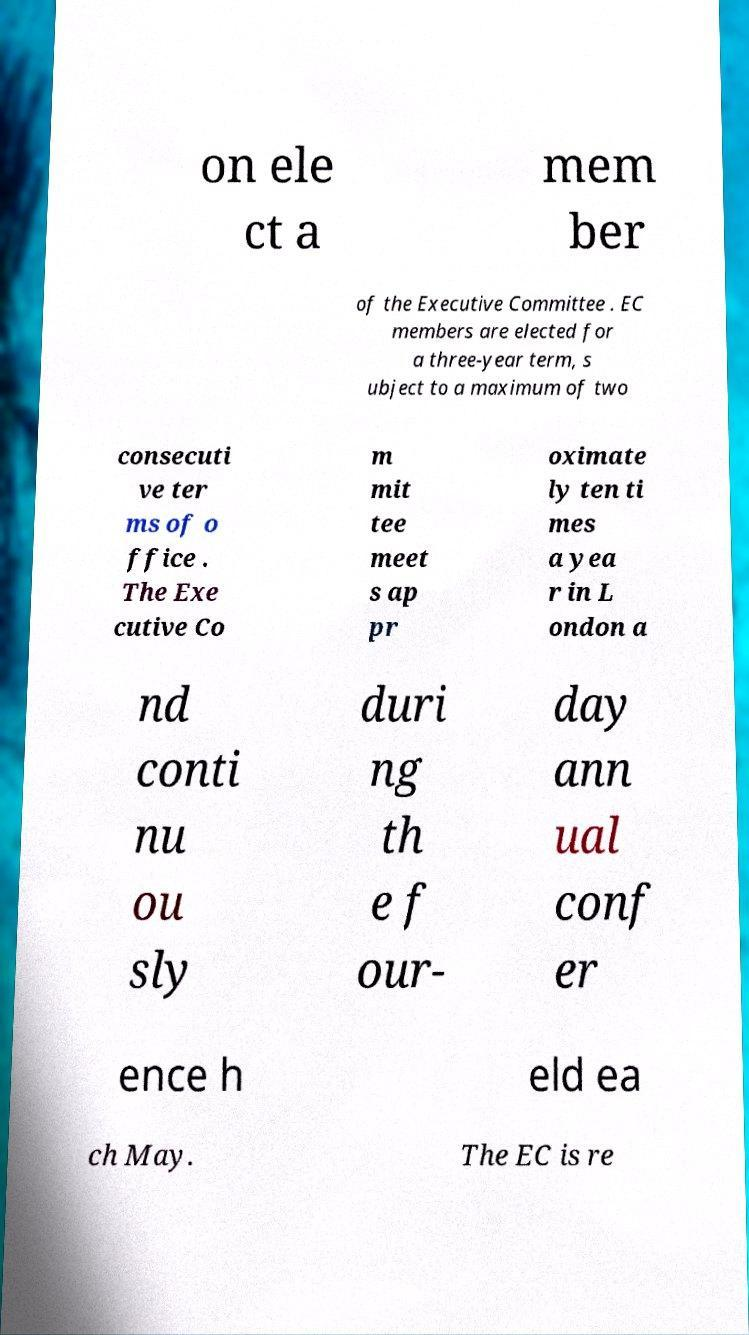Could you assist in decoding the text presented in this image and type it out clearly? on ele ct a mem ber of the Executive Committee . EC members are elected for a three-year term, s ubject to a maximum of two consecuti ve ter ms of o ffice . The Exe cutive Co m mit tee meet s ap pr oximate ly ten ti mes a yea r in L ondon a nd conti nu ou sly duri ng th e f our- day ann ual conf er ence h eld ea ch May. The EC is re 